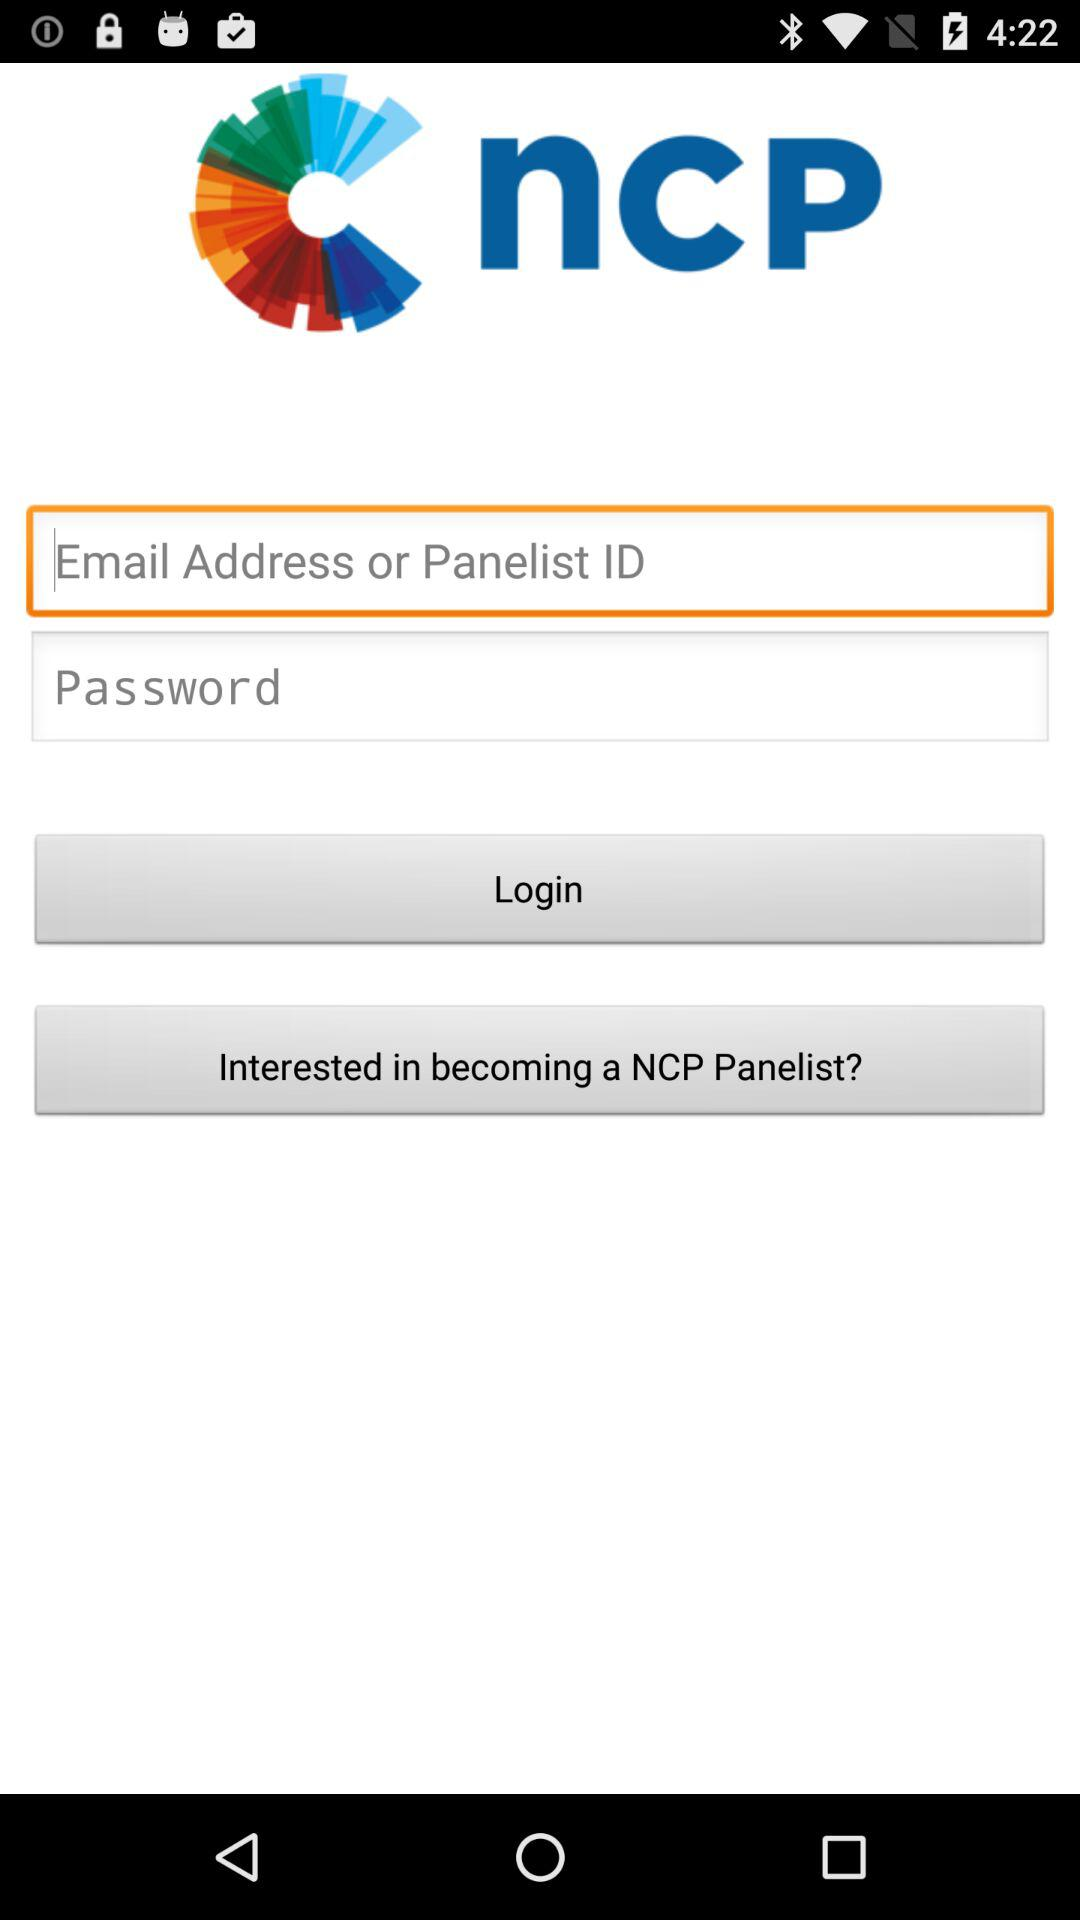What are the requirements to get a login? The requirements to get a login are "Email Address or Panelist ID" and "Password". 